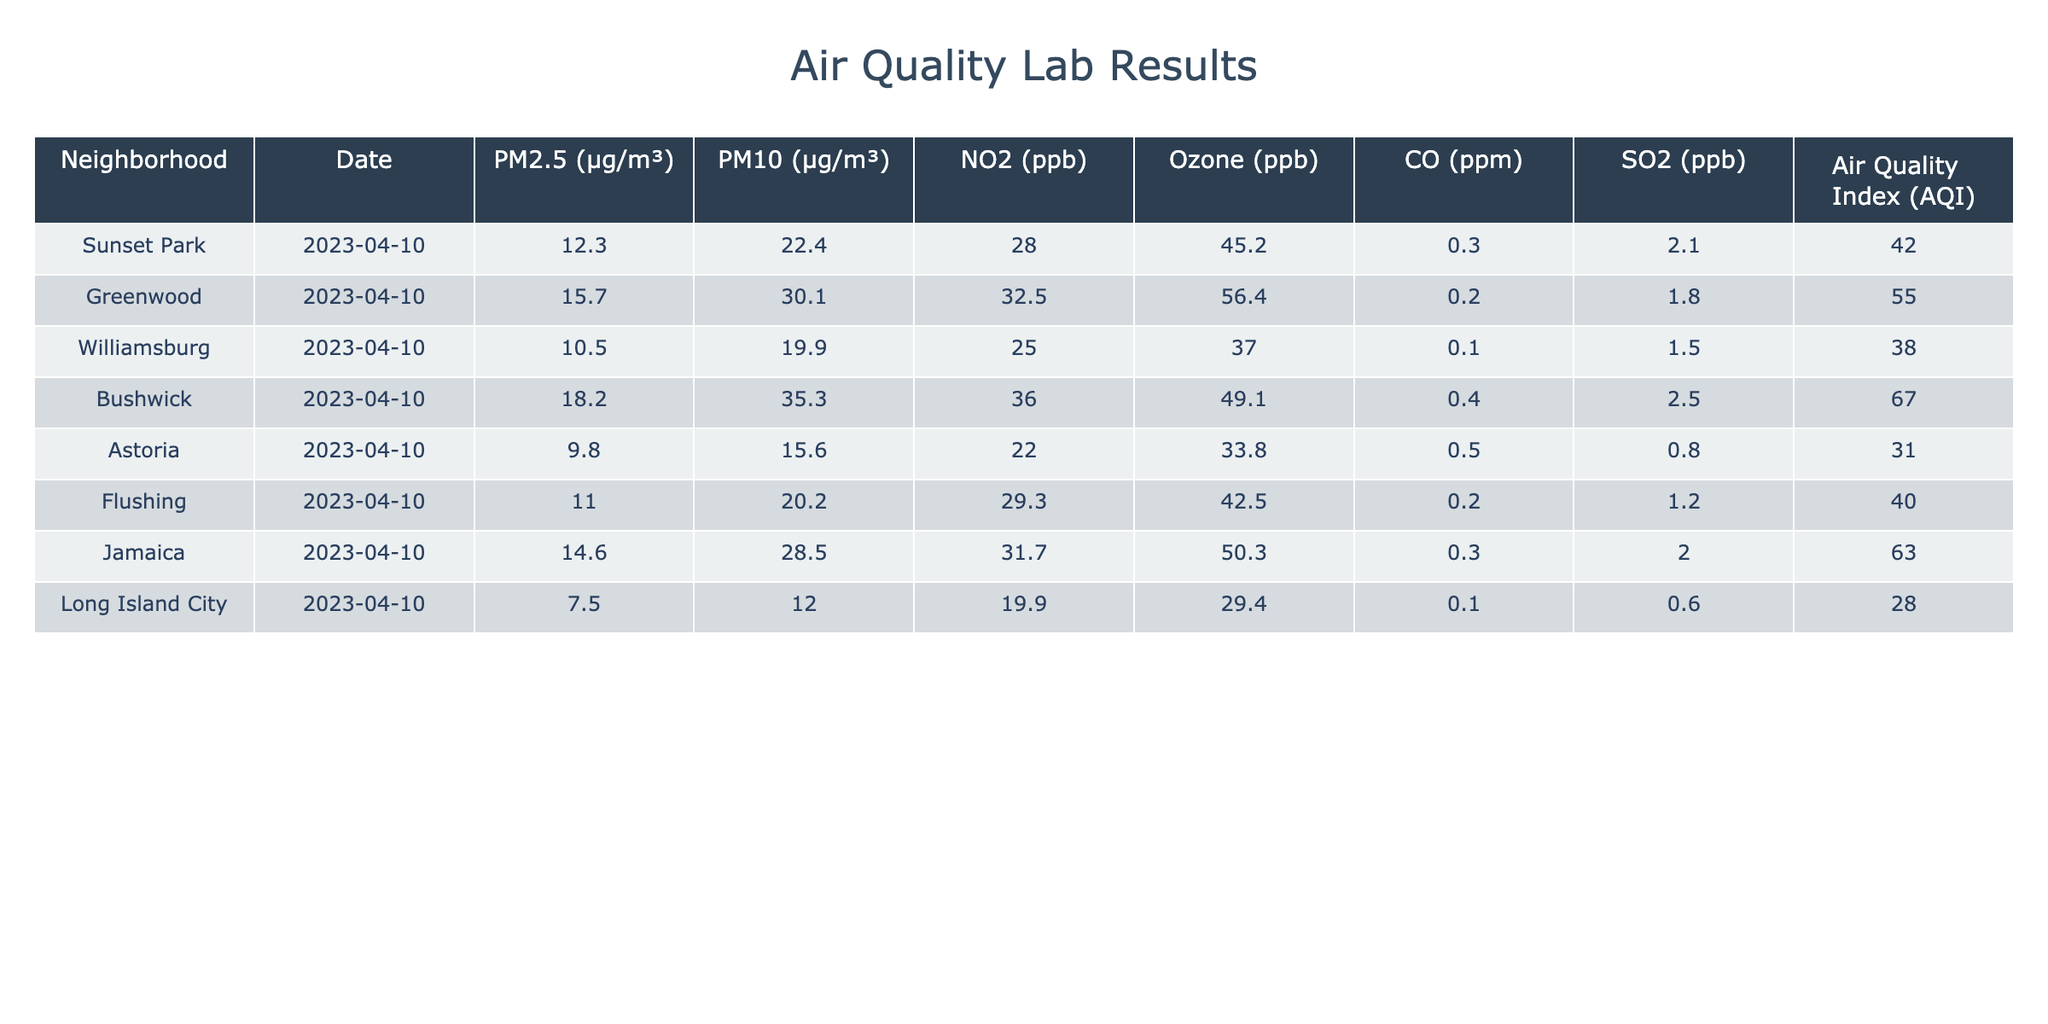What is the AQI value for Sunset Park? The AQI value for Sunset Park is explicitly listed in the table under the column "Air Quality Index (AQI)" which states 42 for the date mentioned.
Answer: 42 Which neighborhood has the highest level of PM2.5? By examining the PM2.5 values for each neighborhood, Bushwick has the highest value at 18.2 µg/m³.
Answer: Bushwick What is the average PM10 level across all neighborhoods? The PM10 values are 22.4, 30.1, 19.9, 35.3, 15.6, 20.2, 28.5, and 12.0 µg/m³. Adding them up gives 172.0, and there are 8 neighborhoods, so the average is 172/8 = 21.5 µg/m³.
Answer: 21.5 Is the NO2 level in Long Island City higher than in Astoria? The NO2 level for Long Island City is 19.9 ppb and for Astoria, it is 22.0 ppb. Since 19.9 is less than 22.0, the NO2 level in Long Island City is not higher.
Answer: No Which neighborhood has the lowest level of Ozone? From the table, Long Island City has the lowest level of Ozone at 29.4 ppb compared to other neighborhoods listed.
Answer: Long Island City What is the difference in PM2.5 levels between Bushwick and Greenwood? The PM2.5 level for Bushwick is 18.2 µg/m³ and for Greenwood, it is 15.7 µg/m³. The difference is 18.2 - 15.7 = 2.5 µg/m³.
Answer: 2.5 Are there any neighborhoods with an AQI value above 60? The AQI values listed are 42, 55, 67, 63, 31, 40, 28 from various neighborhoods. Checking through these, both Bushwick and Jamaica have AQI values over 60. Hence, there are neighborhoods that meet this criteria.
Answer: Yes What is the highest CO level recorded in this table? The CO levels are found under the "CO (ppm)" column which lists values of 0.3, 0.2, 0.1, 0.4, 0.5, 0.2, 0.3, and 0.1 ppm. The highest value among these is 0.5 ppm from Astoria.
Answer: 0.5 Which neighborhood has a PM2.5 level less than 12 µg/m³? Checking the PM2.5 values, they are 12.3, 15.7, 10.5, 18.2, 9.8, 11.0, 14.6, and 7.5 µg/m³. Only Long Island City with 7.5 µg/m³ is less than 12 µg/m³.
Answer: Long Island City 